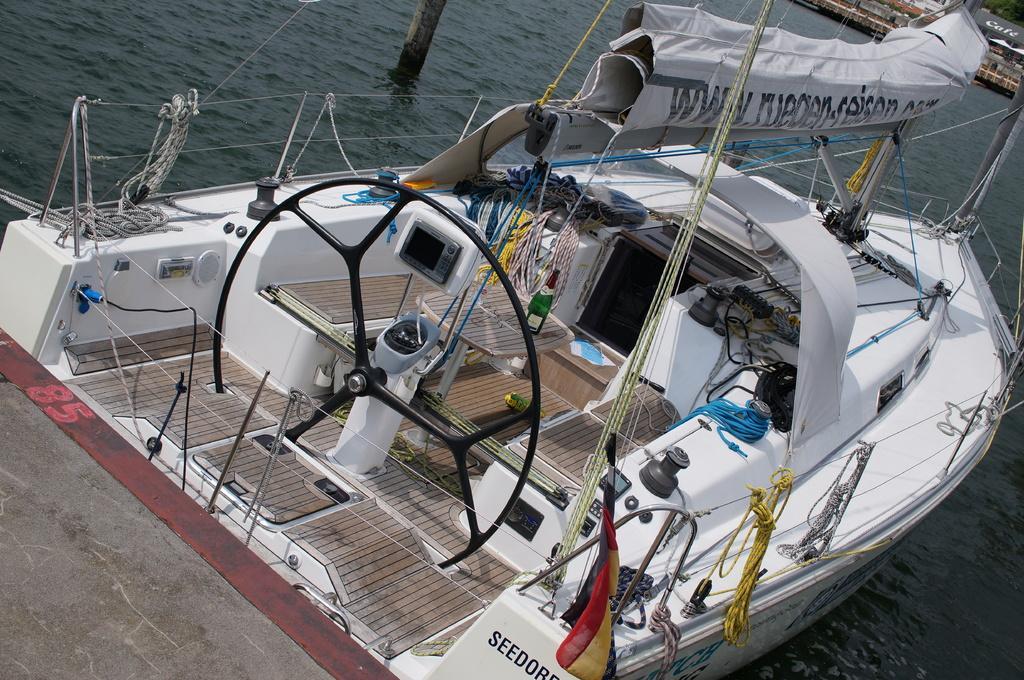How would you summarize this image in a sentence or two? In this image we can see boat in water. 